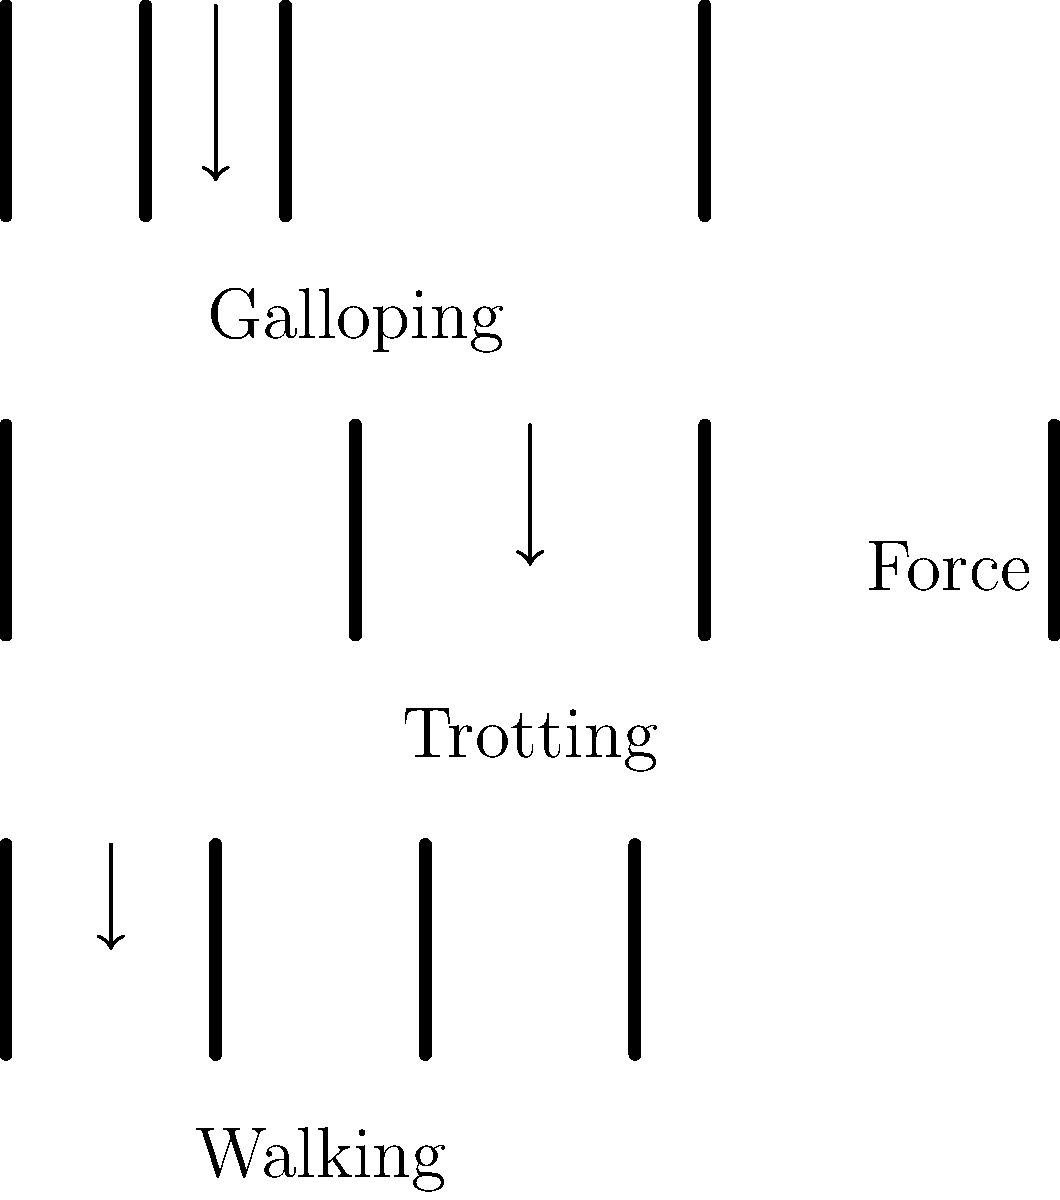As a museum curator specializing in equestrian history, you're designing an exhibit on the biomechanics of horses. Which gait shown in the diagram experiences the highest peak force on a single leg, and why is this relevant to the horse's skeletal structure and historical use? To answer this question, let's analyze the force distribution on a horse's legs during different gaits:

1. Walking: In this gait, the horse has three or four legs on the ground at any given time. The force is distributed relatively evenly among these legs, resulting in lower peak forces on each leg.

2. Trotting: During a trot, the horse moves its legs in diagonal pairs. At any given moment, two legs are on the ground, bearing the entire weight of the horse. This results in higher forces on each leg compared to walking.

3. Galloping: This is the fastest gait, where all four legs can be off the ground simultaneously for a brief moment. When landing, often only one leg (typically a front leg) bears the entire weight of the horse plus the additional force from the momentum of the gallop.

Based on the diagram, the galloping gait shows the longest arrow representing force, indicating the highest peak force on a single leg.

This is relevant to the horse's skeletal structure because:

a) The horse's leg bones and joints have evolved to withstand these high forces, particularly in the front legs.
b) The horse's front legs are designed more for impact absorption, while the hind legs are optimized for propulsion.

Historically, this information is significant because:

1. It influenced how horses were used in various activities (e.g., racing, warfare, agriculture).
2. It affected breeding practices to develop horses with stronger legs for specific purposes.
3. It impacted the design of horseshoes and other equipment to protect horses' legs during high-impact activities.

Understanding these biomechanics helps curators like yourself contextualize artifacts related to horse care, training, and use throughout history.
Answer: Galloping; highest impact on legs affects historical use and equipment design. 